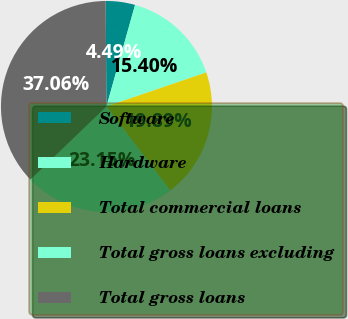Convert chart. <chart><loc_0><loc_0><loc_500><loc_500><pie_chart><fcel>Software<fcel>Hardware<fcel>Total commercial loans<fcel>Total gross loans excluding<fcel>Total gross loans<nl><fcel>4.49%<fcel>15.4%<fcel>19.89%<fcel>23.15%<fcel>37.06%<nl></chart> 